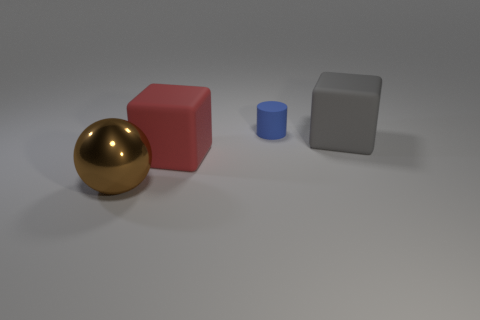What is the size of the matte thing behind the big gray cube?
Give a very brief answer. Small. Is the large gray object made of the same material as the brown ball?
Your response must be concise. No. What is the size of the rubber block to the right of the rubber block that is to the left of the big rubber block that is on the right side of the small cylinder?
Ensure brevity in your answer.  Large. What shape is the brown object that is the same size as the gray matte object?
Provide a short and direct response. Sphere. How many large objects are brown rubber blocks or blue matte cylinders?
Your answer should be compact. 0. Is there a red block behind the big object that is in front of the large cube that is to the left of the blue thing?
Your response must be concise. Yes. Are there any metal spheres that have the same size as the blue thing?
Your answer should be compact. No. There is a gray thing that is the same size as the brown ball; what is it made of?
Give a very brief answer. Rubber. There is a brown metallic thing; is its size the same as the rubber object that is on the left side of the small matte thing?
Your answer should be very brief. Yes. How many metal objects are purple cubes or big blocks?
Keep it short and to the point. 0. 